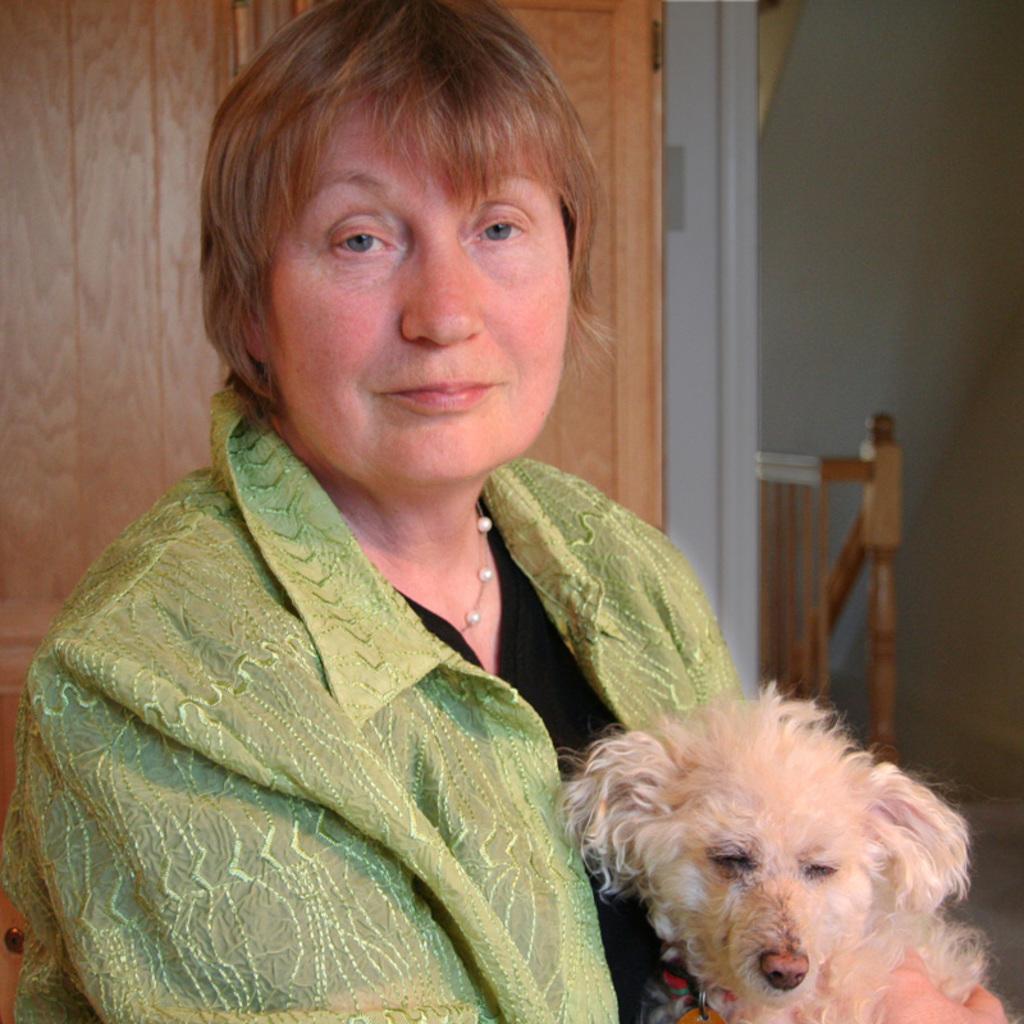In one or two sentences, can you explain what this image depicts? This is the picture of a woman in green shirt holding a dog. Background of the woman is a wooden door and a wall which is in white color. 